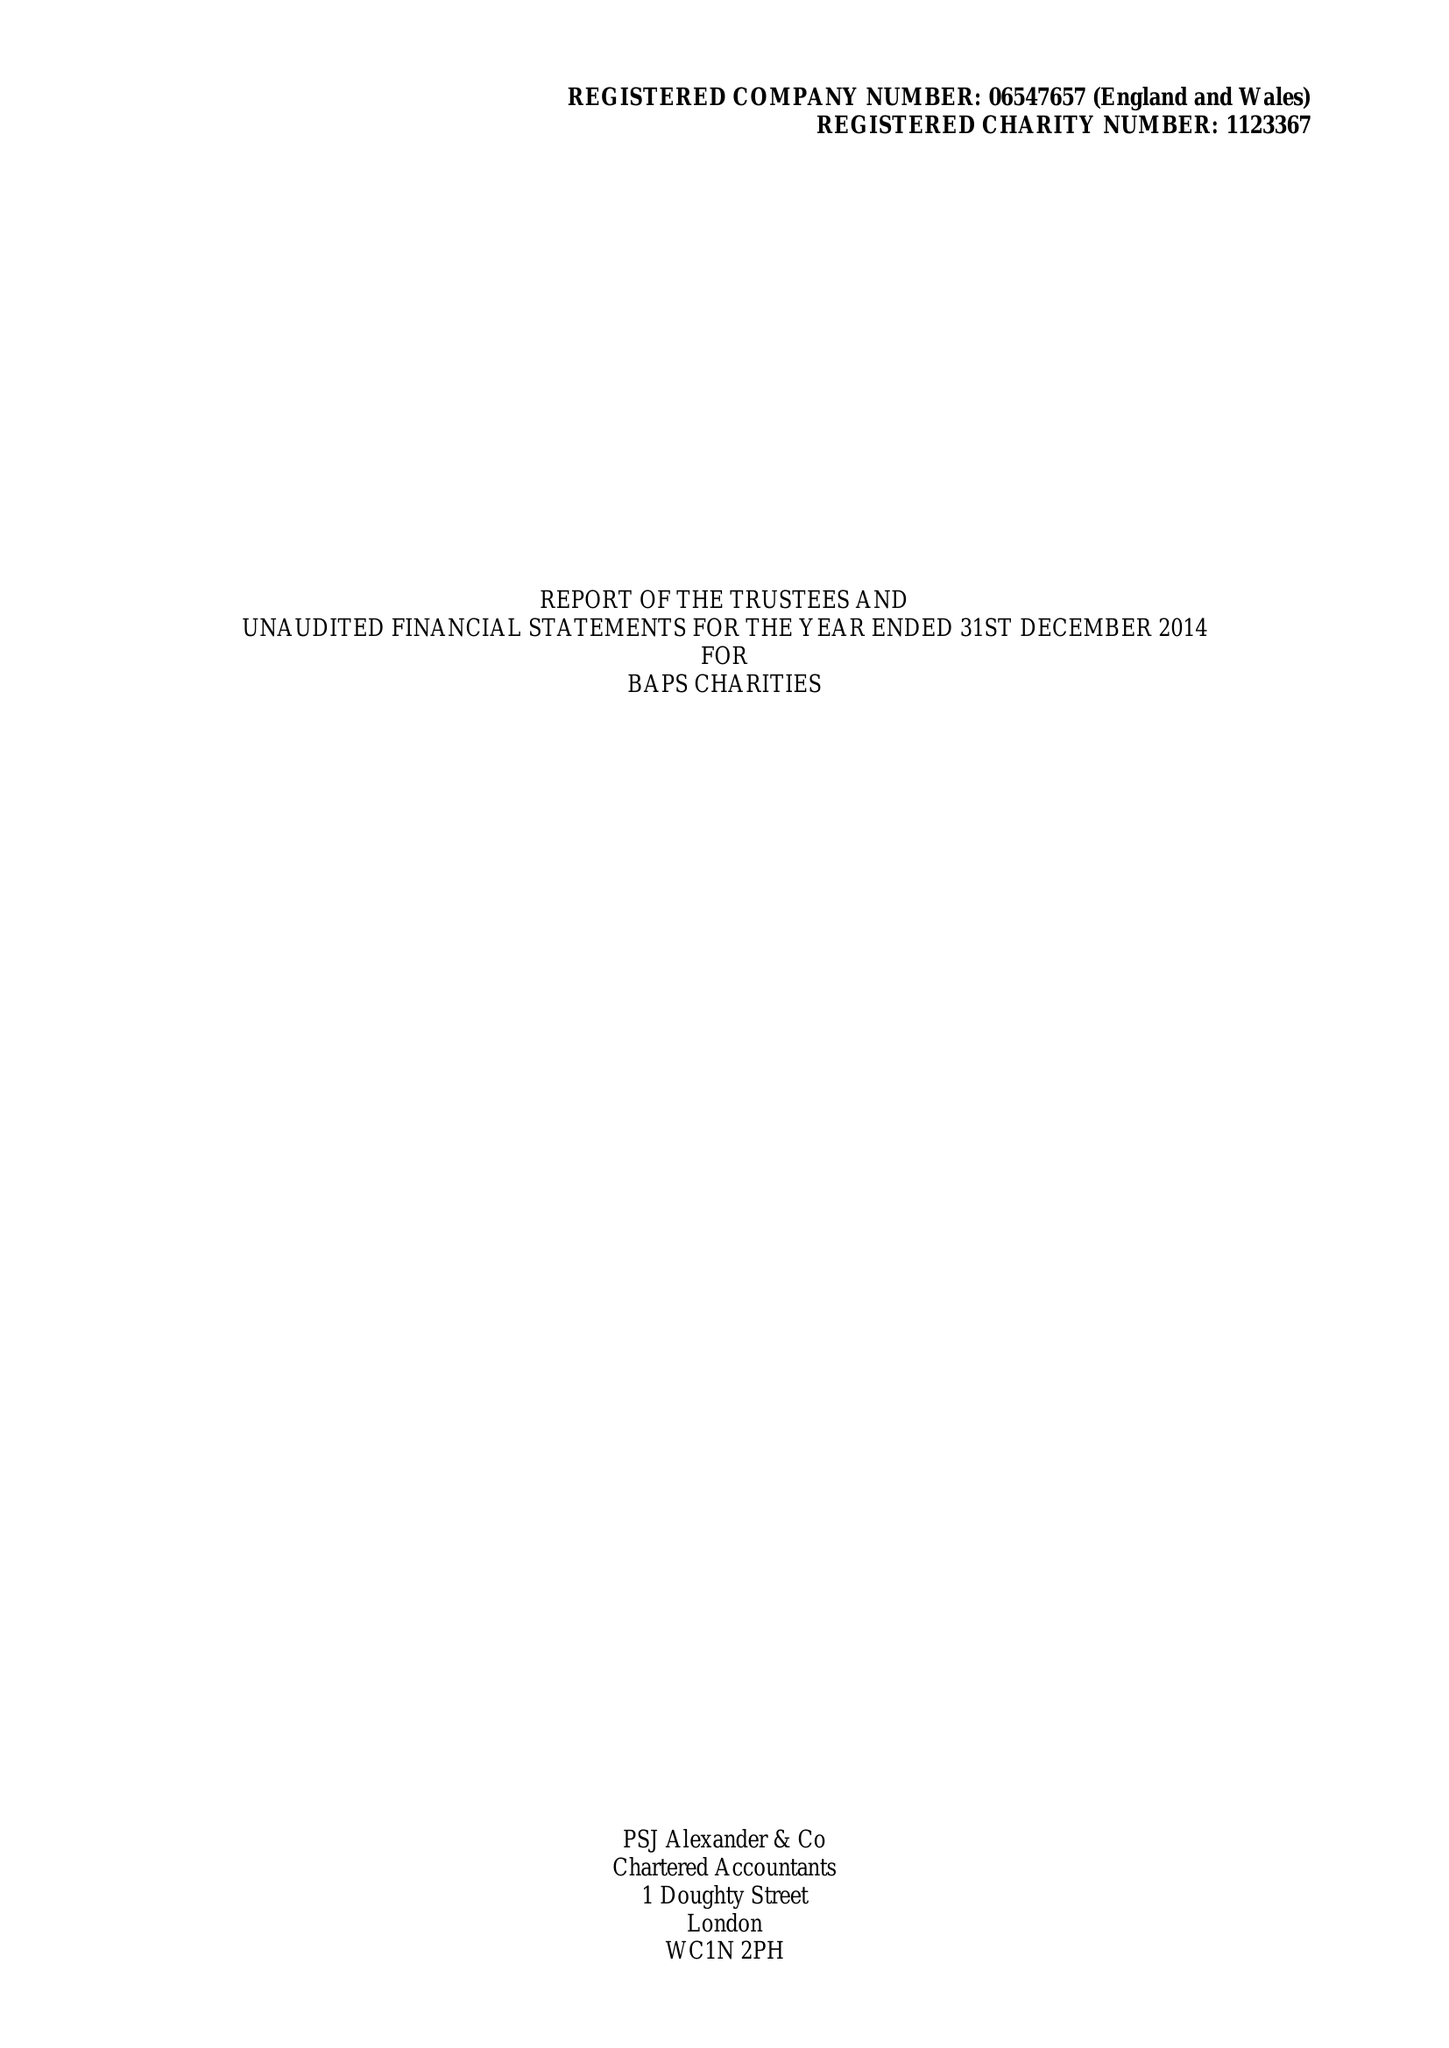What is the value for the address__post_town?
Answer the question using a single word or phrase. LONDON 